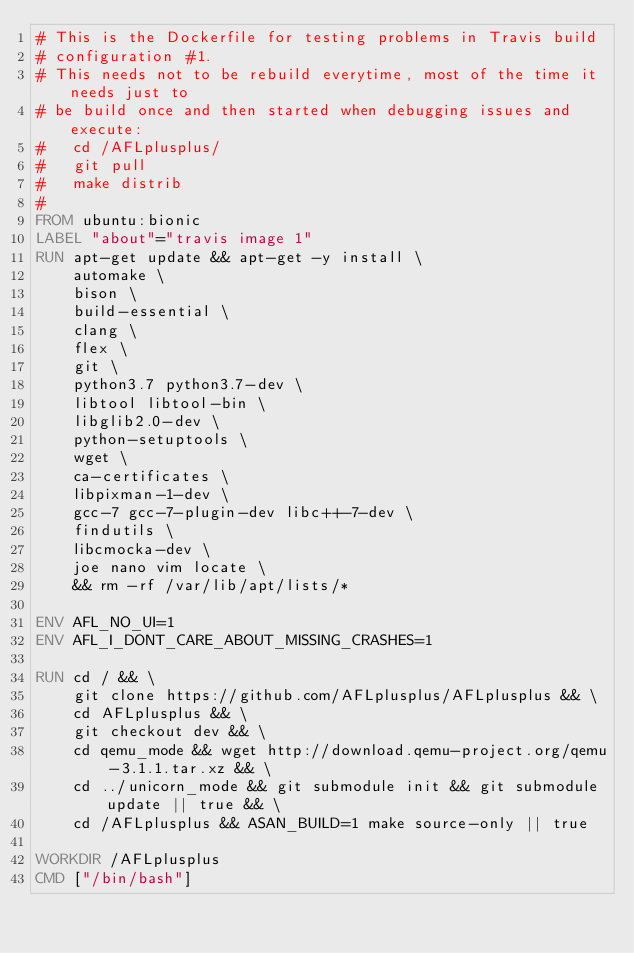Convert code to text. <code><loc_0><loc_0><loc_500><loc_500><_Dockerfile_># This is the Dockerfile for testing problems in Travis build
# configuration #1.
# This needs not to be rebuild everytime, most of the time it needs just to
# be build once and then started when debugging issues and execute:
#   cd /AFLplusplus/
#   git pull
#   make distrib
#
FROM ubuntu:bionic
LABEL "about"="travis image 1"
RUN apt-get update && apt-get -y install \
    automake \
    bison \
    build-essential \
    clang \
    flex \
    git \
    python3.7 python3.7-dev \
    libtool libtool-bin \
    libglib2.0-dev \
    python-setuptools \
    wget \
    ca-certificates \
    libpixman-1-dev \
    gcc-7 gcc-7-plugin-dev libc++-7-dev \
    findutils \
    libcmocka-dev \
    joe nano vim locate \
    && rm -rf /var/lib/apt/lists/*

ENV AFL_NO_UI=1
ENV AFL_I_DONT_CARE_ABOUT_MISSING_CRASHES=1

RUN cd / && \
    git clone https://github.com/AFLplusplus/AFLplusplus && \
    cd AFLplusplus && \
    git checkout dev && \
    cd qemu_mode && wget http://download.qemu-project.org/qemu-3.1.1.tar.xz && \
    cd ../unicorn_mode && git submodule init && git submodule update || true && \
    cd /AFLplusplus && ASAN_BUILD=1 make source-only || true

WORKDIR /AFLplusplus
CMD ["/bin/bash"]
</code> 